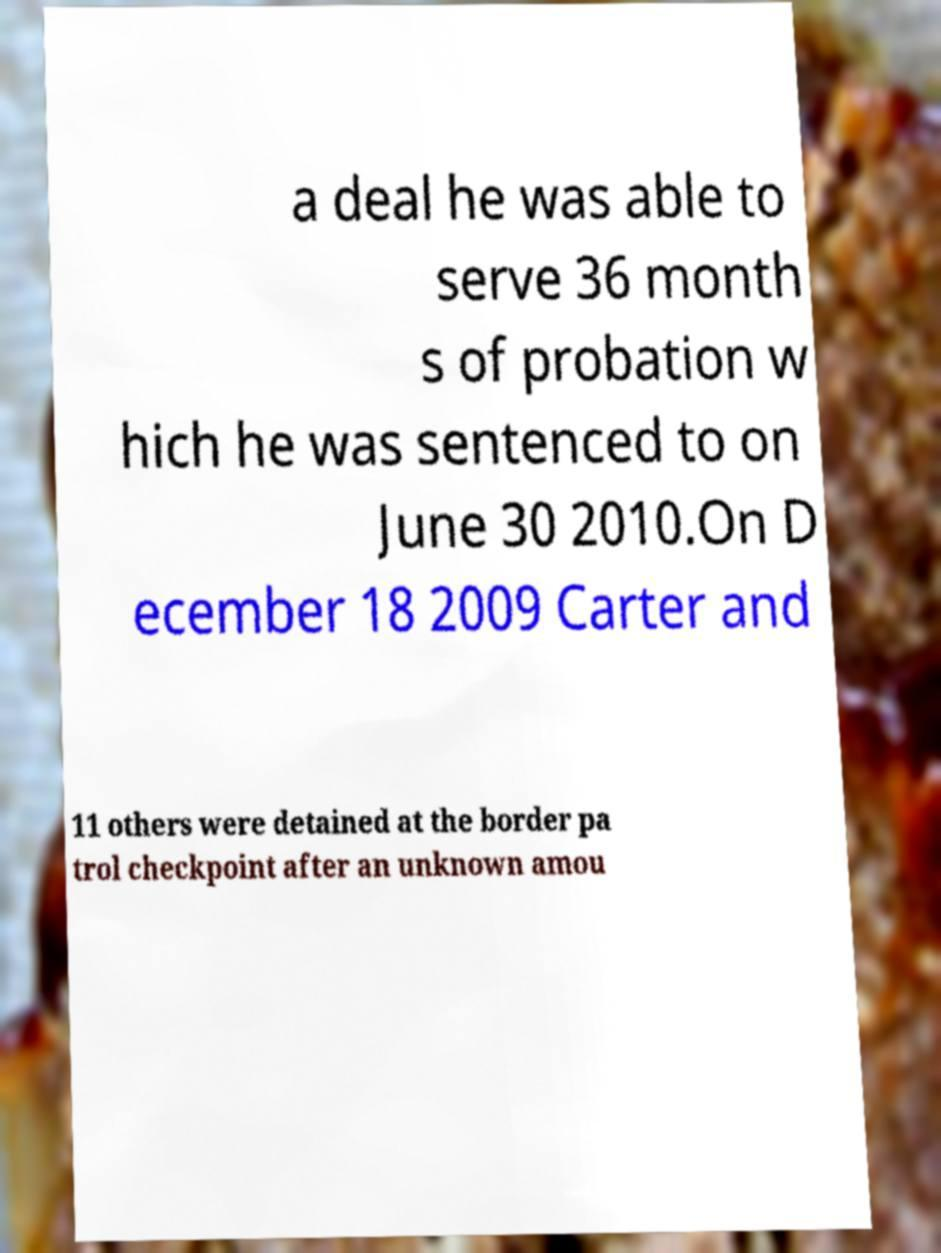Could you extract and type out the text from this image? a deal he was able to serve 36 month s of probation w hich he was sentenced to on June 30 2010.On D ecember 18 2009 Carter and 11 others were detained at the border pa trol checkpoint after an unknown amou 